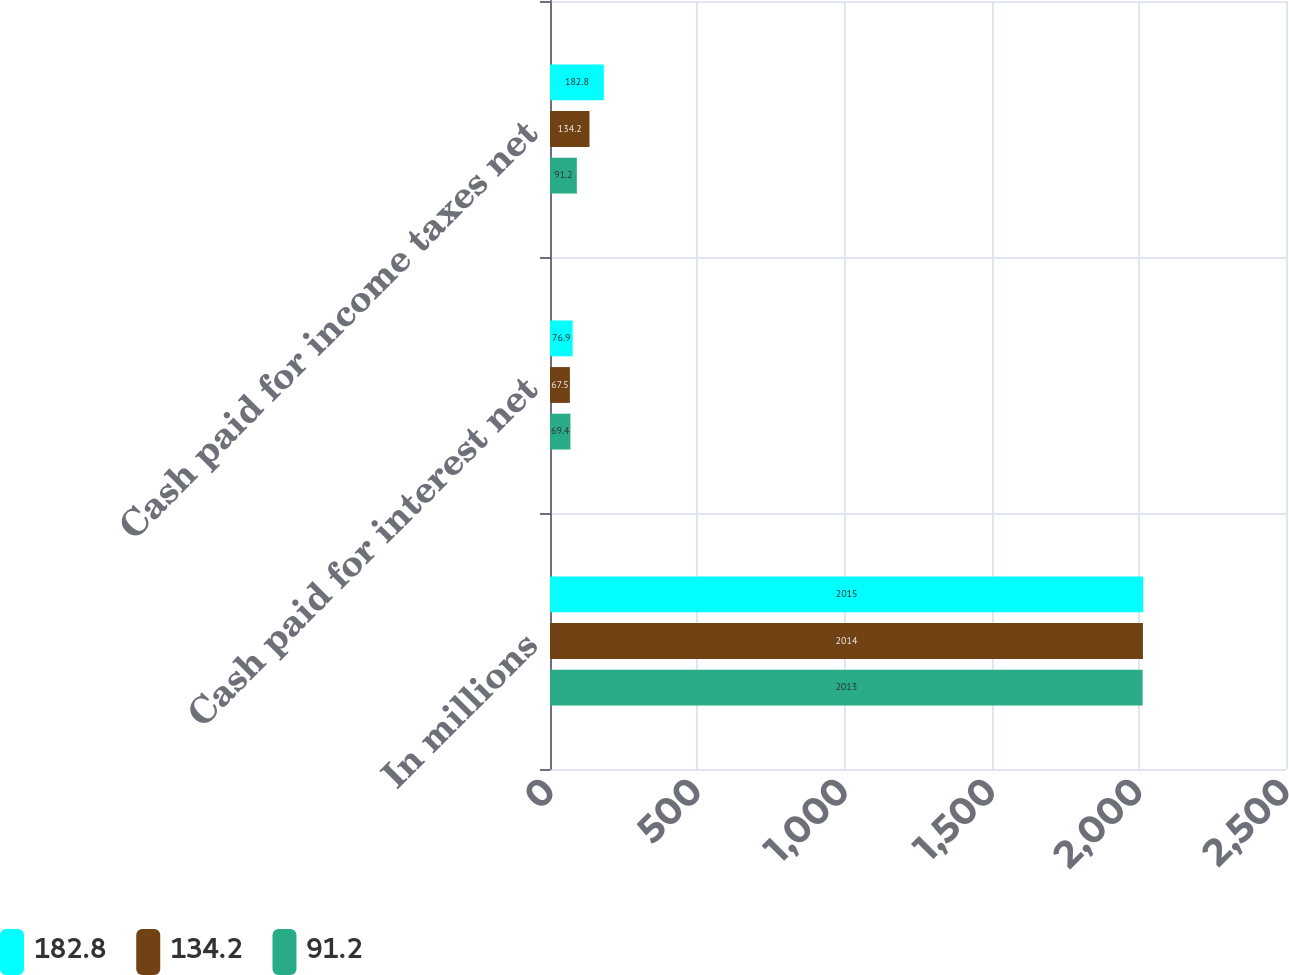Convert chart. <chart><loc_0><loc_0><loc_500><loc_500><stacked_bar_chart><ecel><fcel>In millions<fcel>Cash paid for interest net<fcel>Cash paid for income taxes net<nl><fcel>182.8<fcel>2015<fcel>76.9<fcel>182.8<nl><fcel>134.2<fcel>2014<fcel>67.5<fcel>134.2<nl><fcel>91.2<fcel>2013<fcel>69.4<fcel>91.2<nl></chart> 